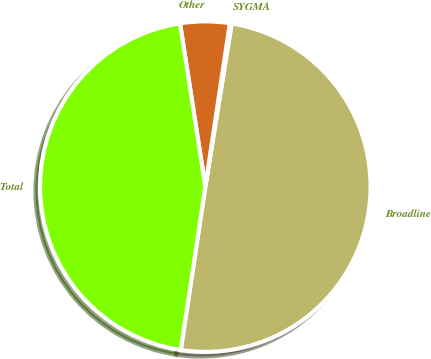<chart> <loc_0><loc_0><loc_500><loc_500><pie_chart><fcel>Broadline<fcel>SYGMA<fcel>Other<fcel>Total<nl><fcel>49.82%<fcel>0.18%<fcel>4.82%<fcel>45.18%<nl></chart> 